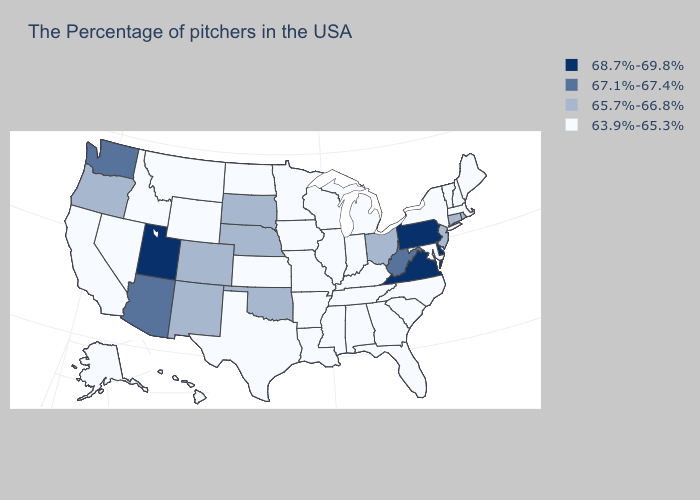What is the value of Massachusetts?
Quick response, please. 63.9%-65.3%. Which states have the lowest value in the USA?
Concise answer only. Maine, Massachusetts, New Hampshire, Vermont, New York, Maryland, North Carolina, South Carolina, Florida, Georgia, Michigan, Kentucky, Indiana, Alabama, Tennessee, Wisconsin, Illinois, Mississippi, Louisiana, Missouri, Arkansas, Minnesota, Iowa, Kansas, Texas, North Dakota, Wyoming, Montana, Idaho, Nevada, California, Alaska, Hawaii. Which states have the lowest value in the USA?
Be succinct. Maine, Massachusetts, New Hampshire, Vermont, New York, Maryland, North Carolina, South Carolina, Florida, Georgia, Michigan, Kentucky, Indiana, Alabama, Tennessee, Wisconsin, Illinois, Mississippi, Louisiana, Missouri, Arkansas, Minnesota, Iowa, Kansas, Texas, North Dakota, Wyoming, Montana, Idaho, Nevada, California, Alaska, Hawaii. What is the lowest value in the MidWest?
Answer briefly. 63.9%-65.3%. What is the value of Kansas?
Give a very brief answer. 63.9%-65.3%. What is the highest value in states that border North Dakota?
Keep it brief. 65.7%-66.8%. How many symbols are there in the legend?
Write a very short answer. 4. Among the states that border Oklahoma , does Colorado have the highest value?
Keep it brief. Yes. What is the value of Tennessee?
Concise answer only. 63.9%-65.3%. Which states have the lowest value in the USA?
Give a very brief answer. Maine, Massachusetts, New Hampshire, Vermont, New York, Maryland, North Carolina, South Carolina, Florida, Georgia, Michigan, Kentucky, Indiana, Alabama, Tennessee, Wisconsin, Illinois, Mississippi, Louisiana, Missouri, Arkansas, Minnesota, Iowa, Kansas, Texas, North Dakota, Wyoming, Montana, Idaho, Nevada, California, Alaska, Hawaii. What is the highest value in the Northeast ?
Quick response, please. 68.7%-69.8%. What is the lowest value in states that border North Dakota?
Be succinct. 63.9%-65.3%. Does Idaho have a higher value than Wyoming?
Quick response, please. No. What is the value of Mississippi?
Give a very brief answer. 63.9%-65.3%. Name the states that have a value in the range 63.9%-65.3%?
Short answer required. Maine, Massachusetts, New Hampshire, Vermont, New York, Maryland, North Carolina, South Carolina, Florida, Georgia, Michigan, Kentucky, Indiana, Alabama, Tennessee, Wisconsin, Illinois, Mississippi, Louisiana, Missouri, Arkansas, Minnesota, Iowa, Kansas, Texas, North Dakota, Wyoming, Montana, Idaho, Nevada, California, Alaska, Hawaii. 